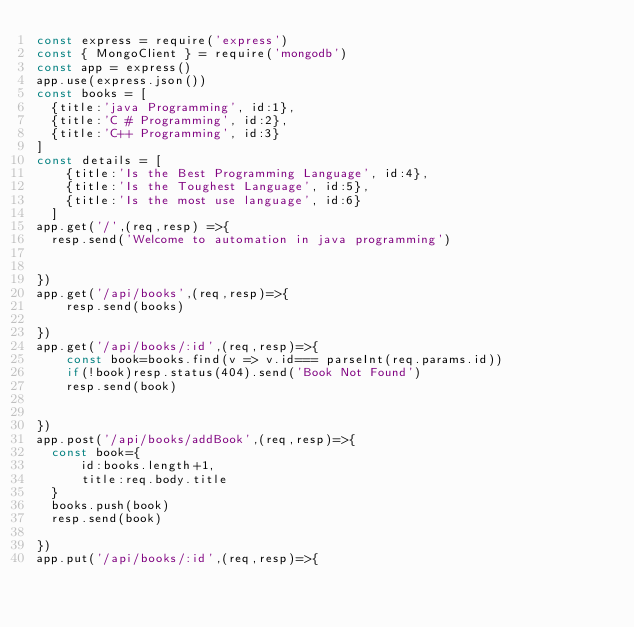<code> <loc_0><loc_0><loc_500><loc_500><_JavaScript_>const express = require('express')
const { MongoClient } = require('mongodb')
const app = express()
app.use(express.json())
const books = [
  {title:'java Programming', id:1},
  {title:'C # Programming', id:2},
  {title:'C++ Programming', id:3}
]
const details = [
    {title:'Is the Best Programming Language', id:4},
    {title:'Is the Toughest Language', id:5},
    {title:'Is the most use language', id:6}
  ]
app.get('/',(req,resp) =>{
  resp.send('Welcome to automation in java programming')


})
app.get('/api/books',(req,resp)=>{
    resp.send(books)
 
})
app.get('/api/books/:id',(req,resp)=>{
    const book=books.find(v => v.id=== parseInt(req.params.id))
    if(!book)resp.status(404).send('Book Not Found')
    resp.send(book)
    

})
app.post('/api/books/addBook',(req,resp)=>{
  const book={
      id:books.length+1,
      title:req.body.title
  }
  books.push(book)
  resp.send(book)
 
})
app.put('/api/books/:id',(req,resp)=>{</code> 